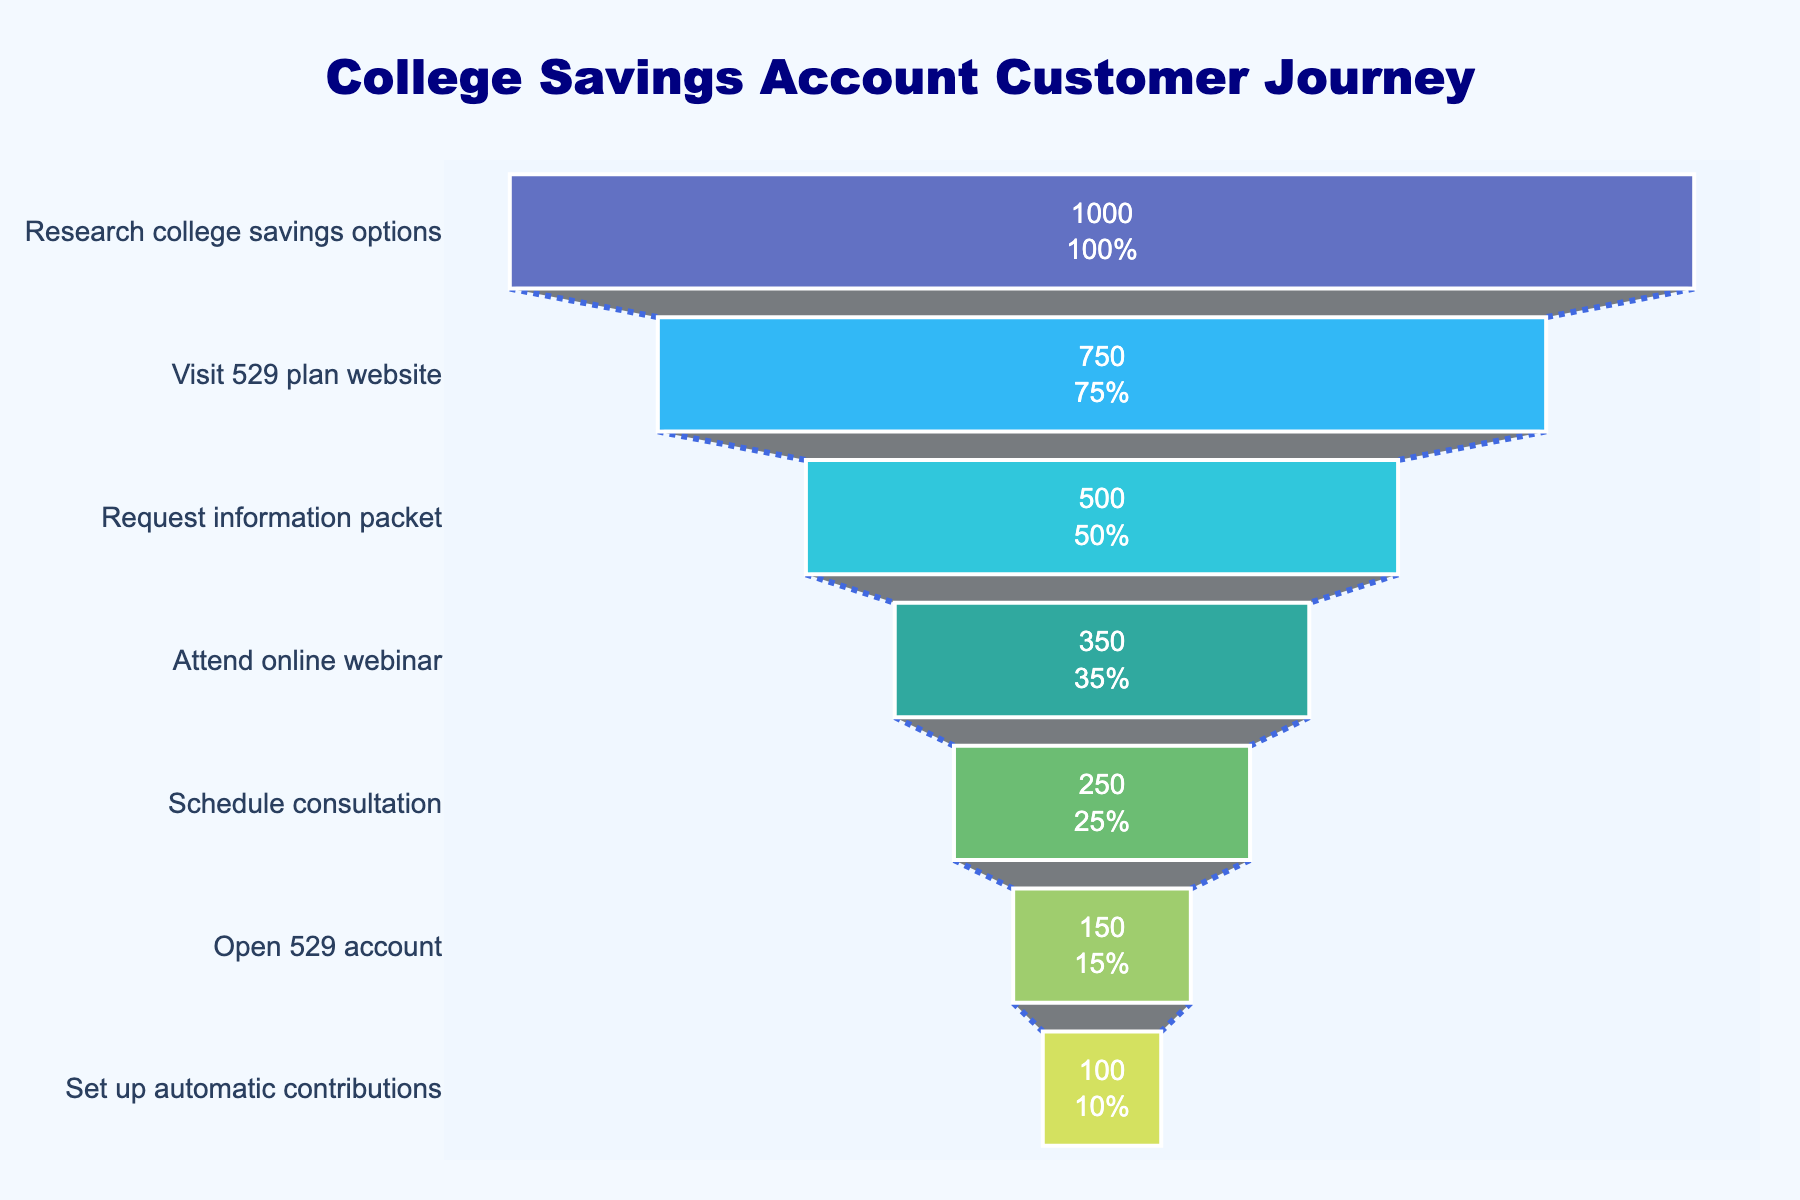What's the title of the funnel chart? The title of the chart can be found at the top of the figure. It reads "College Savings Account Customer Journey".
Answer: College Savings Account Customer Journey How many stages are there in the funnel chart? By counting the distinct stages listed vertically on the left side of the funnel chart, we find a total of 7 stages.
Answer: 7 Which stage saw the highest number of visitors? The stage with the highest number of visitors is the one that appears at the widest part of the funnel, indicating the greatest number of visitors. This is "Research college savings options" with 1000 visitors.
Answer: Research college savings options What's the percentage of visitors that scheduled a consultation out of those who attended the online webinar? Look at the "Schedule consultation" stage's number (250) and the "Attend online webinar" stage's number (350). The percentage is computed as (250/350) * 100%.
Answer: ~71.4% How many visitors converted from visiting the website to requesting an information packet? By examining the numbers, "Visit 529 plan website" has 750 visitors, and "Request information packet" has 500 visitors. So, 750 - 500 visitors converted to the next stage.
Answer: 250 What is the number of visitors that did not open a 529 account after scheduling a consultation? Look at the "Schedule consultation" stage's visitor count (250) and the "Open 529 account" stage's visitor count (150). The difference between these two numbers is 250 - 150.
Answer: 100 Is the number of visitors who set up automatic contributions greater than half of those who opened a 529 account? "Set up automatic contributions" stage has 100 visitors, and "Open 529 account" stage has 150 visitors. Half of 150 is 75, and 100 is greater than 75.
Answer: Yes By how much did the number of visitors drop between attending the online webinar and scheduling a consultation? "Attend online webinar" has 350 visitors, and "Schedule consultation" has 250. The drop is 350 - 250.
Answer: 100 What percentage of the initial visitors set up automatic contributions? The initial number of visitors is 1000, and the final stage's number is 100. The percentage is (100/1000) * 100%.
Answer: 10% Between which two consecutive stages was the largest drop in visitors? Compare the differences in visitor numbers between each consecutive stage pair: 
1. Research college savings options to Visit 529 plan website: 1000 - 750 = 250
2. Visit 529 plan website to Request information packet: 750 - 500 = 250
3. Request information packet to Attend online webinar: 500 - 350 = 150
4. Attend online webinar to Schedule consultation: 350 - 250 = 100
5. Schedule consultation to Open 529 account: 250 - 150 = 100
6. Open 529 account to Set up automatic contributions: 150 - 100 = 50
The largest drop is between the first and second stages and the second and third stages, both dropping by 250 visitors.
Answer: Research college savings options to Visit 529 plan website and Visit 529 plan website to Request information packet 